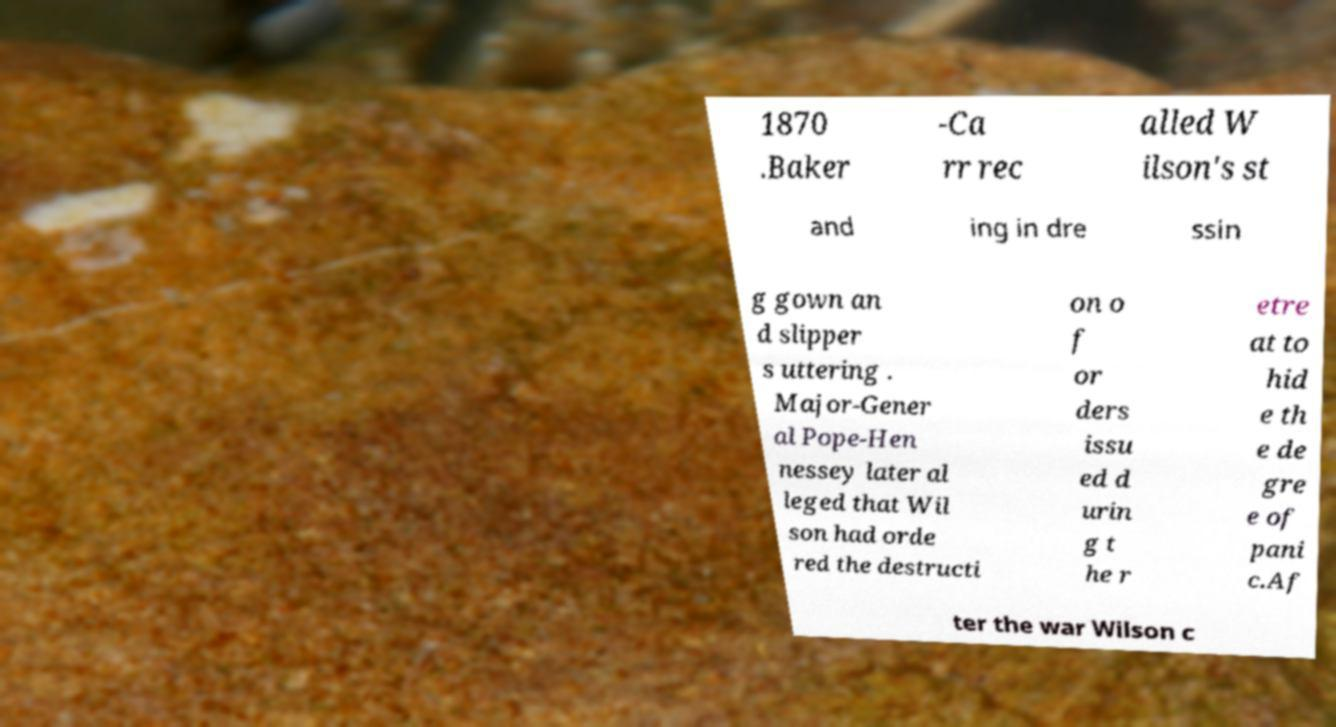For documentation purposes, I need the text within this image transcribed. Could you provide that? 1870 .Baker -Ca rr rec alled W ilson's st and ing in dre ssin g gown an d slipper s uttering . Major-Gener al Pope-Hen nessey later al leged that Wil son had orde red the destructi on o f or ders issu ed d urin g t he r etre at to hid e th e de gre e of pani c.Af ter the war Wilson c 